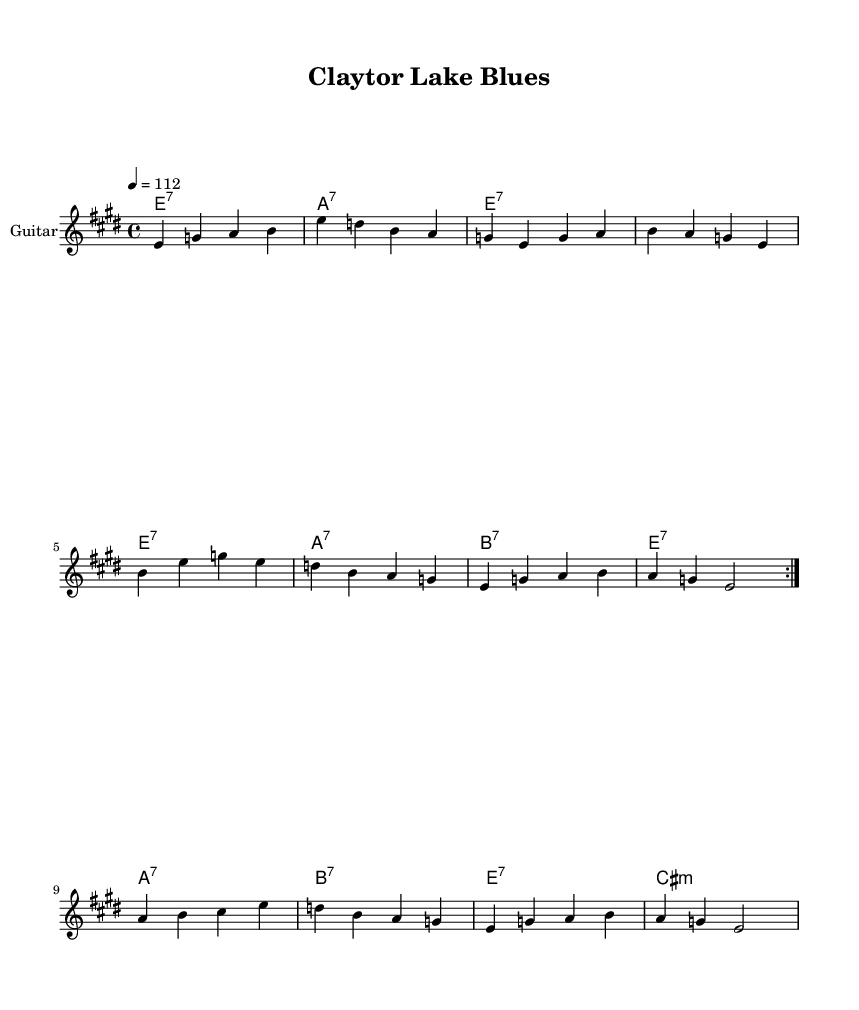What is the key signature of this music? The key signature is E major, indicated by having four sharps, which are F#, C#, G#, and D#. We can identify the key signature by observing the sharp signs in the space beside the clef at the beginning of the score.
Answer: E major What is the time signature of this music? The time signature is 4/4, which is shown at the beginning of the piece and describes the rhythm as having four beats per measure. This can be confirmed by looking at the notational structure that groups the beats into sets of four.
Answer: 4/4 What is the tempo marking for this piece? The tempo marking is 112, meaning the piece should be played at a speed of 112 beats per minute. This information is found near the beginning of the score, typically notated in a standard tempo marking format.
Answer: 112 How many measures are in the first volta section? The first volta section consists of 8 measures, which can be counted by examining the notation until the first repeat sign at the end of the section. Each distinct segment of music separated by bar lines represents a measure.
Answer: 8 What type of chords are predominantly used in this piece? The chords primarily used are seventh chords, specified in the chord section with labels such as e1:7 and a1:7. These chords are commonly found in blues music, creating a distinct sound characterized by the inclusion of the seventh note.
Answer: seventh chords What is the pattern of the melody during the repeated sections? The melody follows a repetitive structure in the first volta, consisting of a sequence of notes that recur before moving to a different section. This is observed in the written music where the same notes play again after the repeat sign.
Answer: repetitive sequence What genre does this piece represent? This piece represents the Blues genre, as indicated by its musical style and the types of chords used, along with the overall structure typically associated with blues rock music.
Answer: Blues 